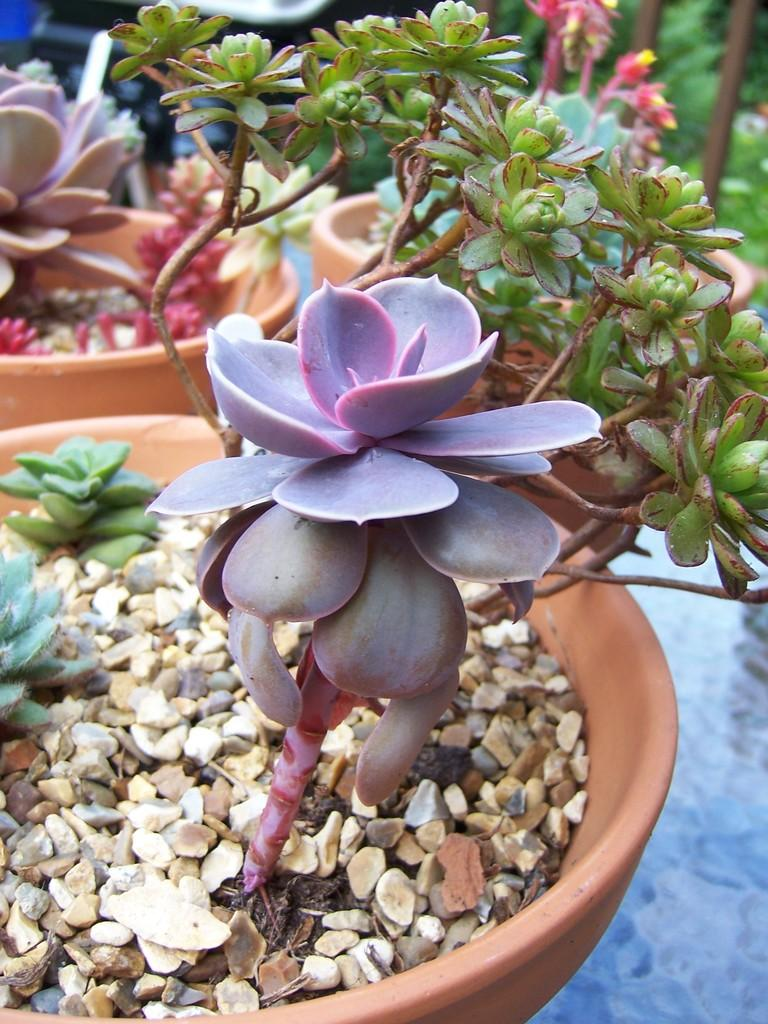What type of living organisms are in the image? There are plants in the image. How are the plants arranged or contained in the image? The plants are in pots. What other elements can be seen in the image besides the plants? There are small stones in the image. What type of knowledge can be gained from the donkey in the image? There is no donkey present in the image, so no knowledge can be gained from a donkey. 